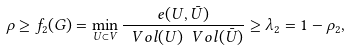Convert formula to latex. <formula><loc_0><loc_0><loc_500><loc_500>\rho \geq f _ { 2 } ( G ) = \min _ { U \subset V } \frac { e ( U , { \bar { U } } ) } { \ V o l ( U ) \ V o l ( { \bar { U } } ) } \geq \lambda _ { 2 } = 1 - \rho _ { 2 } ,</formula> 